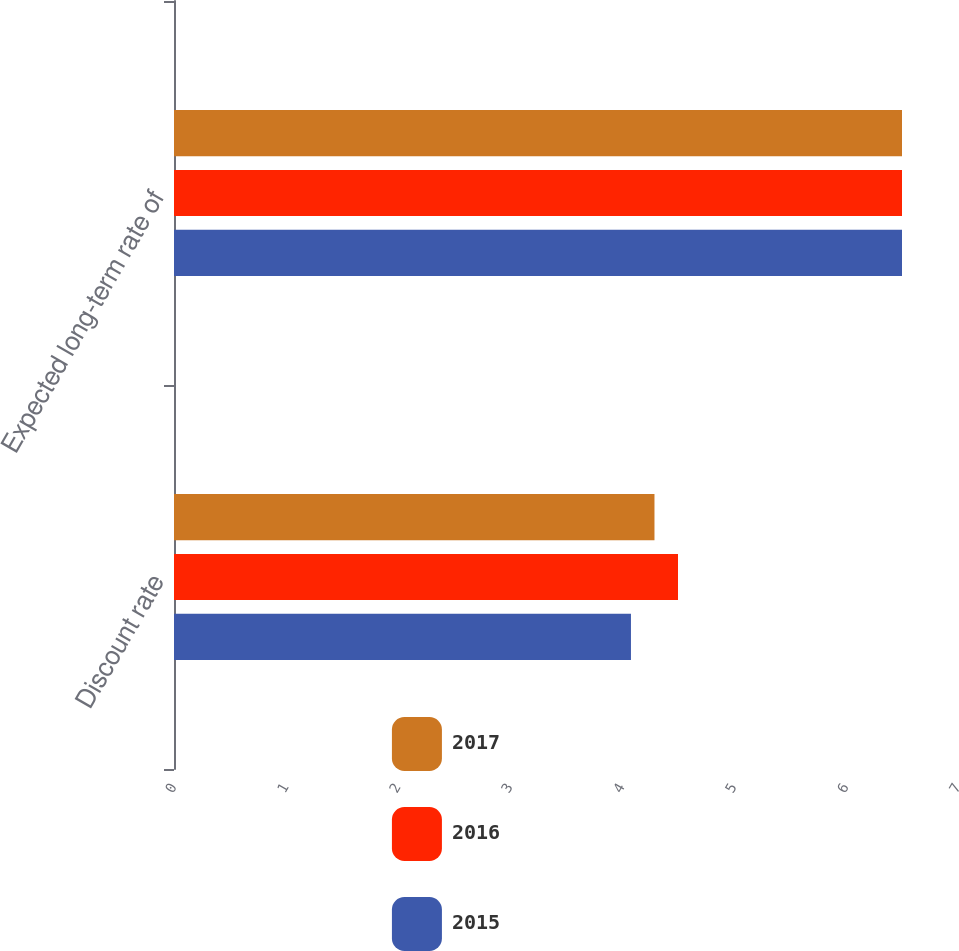Convert chart. <chart><loc_0><loc_0><loc_500><loc_500><stacked_bar_chart><ecel><fcel>Discount rate<fcel>Expected long-term rate of<nl><fcel>2017<fcel>4.29<fcel>6.5<nl><fcel>2016<fcel>4.5<fcel>6.5<nl><fcel>2015<fcel>4.08<fcel>6.5<nl></chart> 